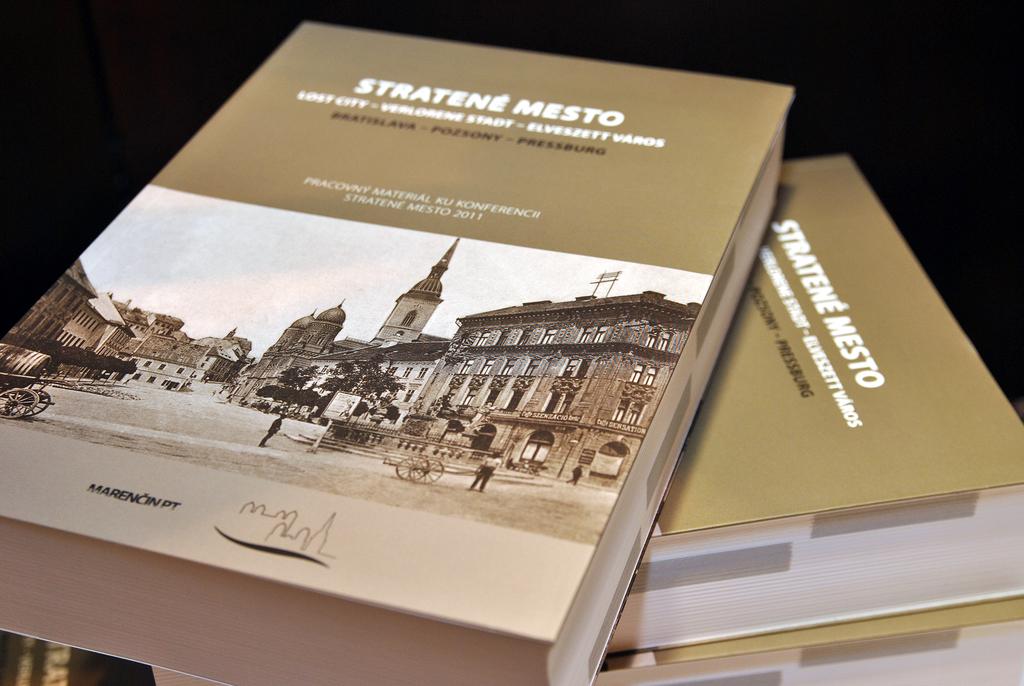Are the books open or close ?
Your answer should be very brief. Answering does not require reading text in the image. What is the book title?
Provide a succinct answer. Stratene mesto. 